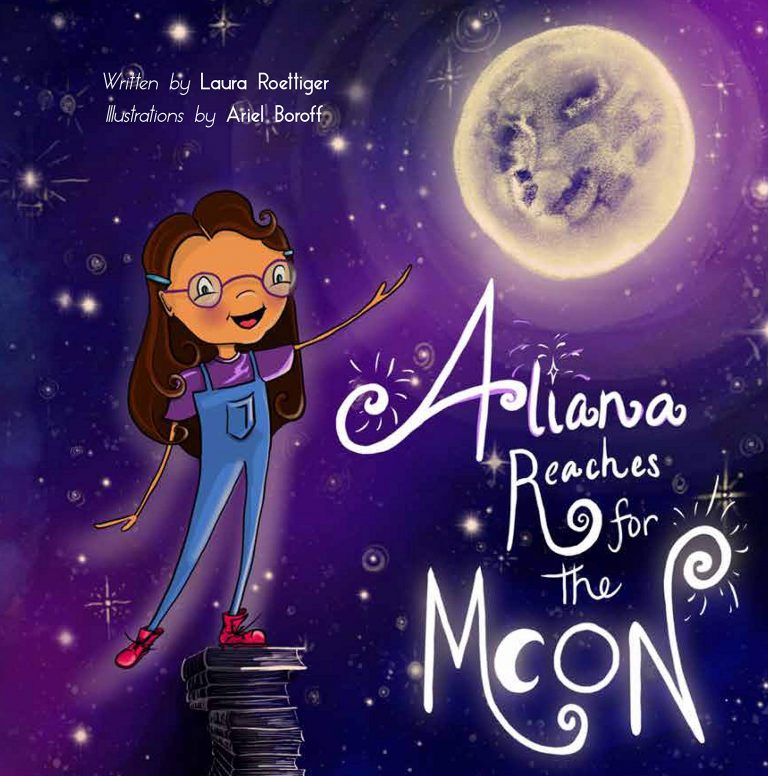What might be the significance of the girl standing on a pile of books as she reaches toward the moon, and how does this relate to the overarching theme suggested by the title of the book? The image of the girl standing on a stack of books as she reaches toward the moon is rich in symbolism. The books represent the accumulation of knowledge, learning, and wisdom. They serve as a foundation elevating her aspirations, suggesting that education and intellectual curiosity are the keys to reaching one's highest goals. The moon typically symbolizes a distant, almost unattainable dream or aspiration. Together, this imagery conveys that through dedication to learning and an imaginative spirit, one can strive for and potentially achieve their loftiest dreams. The book's title, 'Aliana Reaches for the Moon,' reinforces this theme, making it clear that the narrative will explore ambition, dreams, and the pivotal role of education in accomplishing great feats. 